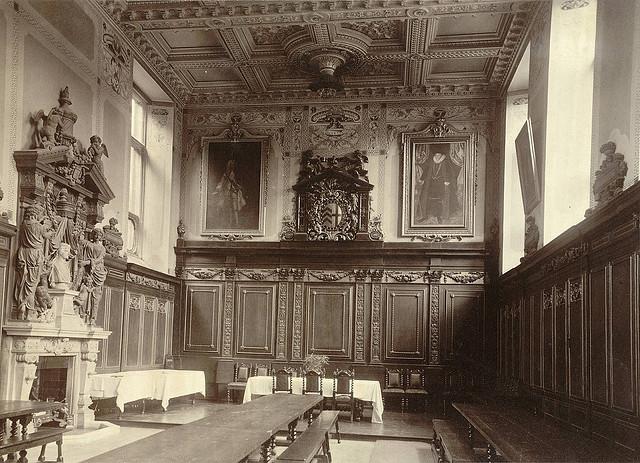What is present in the room?
Give a very brief answer. Table. Is this a church?
Short answer required. Yes. How many paintings are on the wall?
Keep it brief. 2. How many people probably sleep here?
Concise answer only. 0. What type of seating is in this room?
Answer briefly. Benches. 